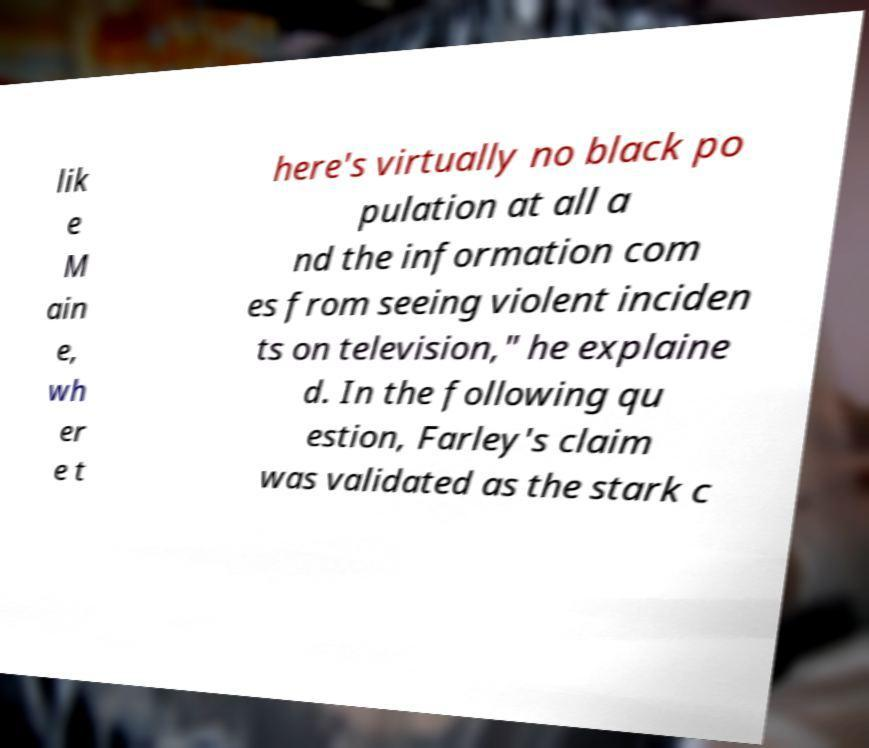Can you read and provide the text displayed in the image?This photo seems to have some interesting text. Can you extract and type it out for me? lik e M ain e, wh er e t here's virtually no black po pulation at all a nd the information com es from seeing violent inciden ts on television," he explaine d. In the following qu estion, Farley's claim was validated as the stark c 